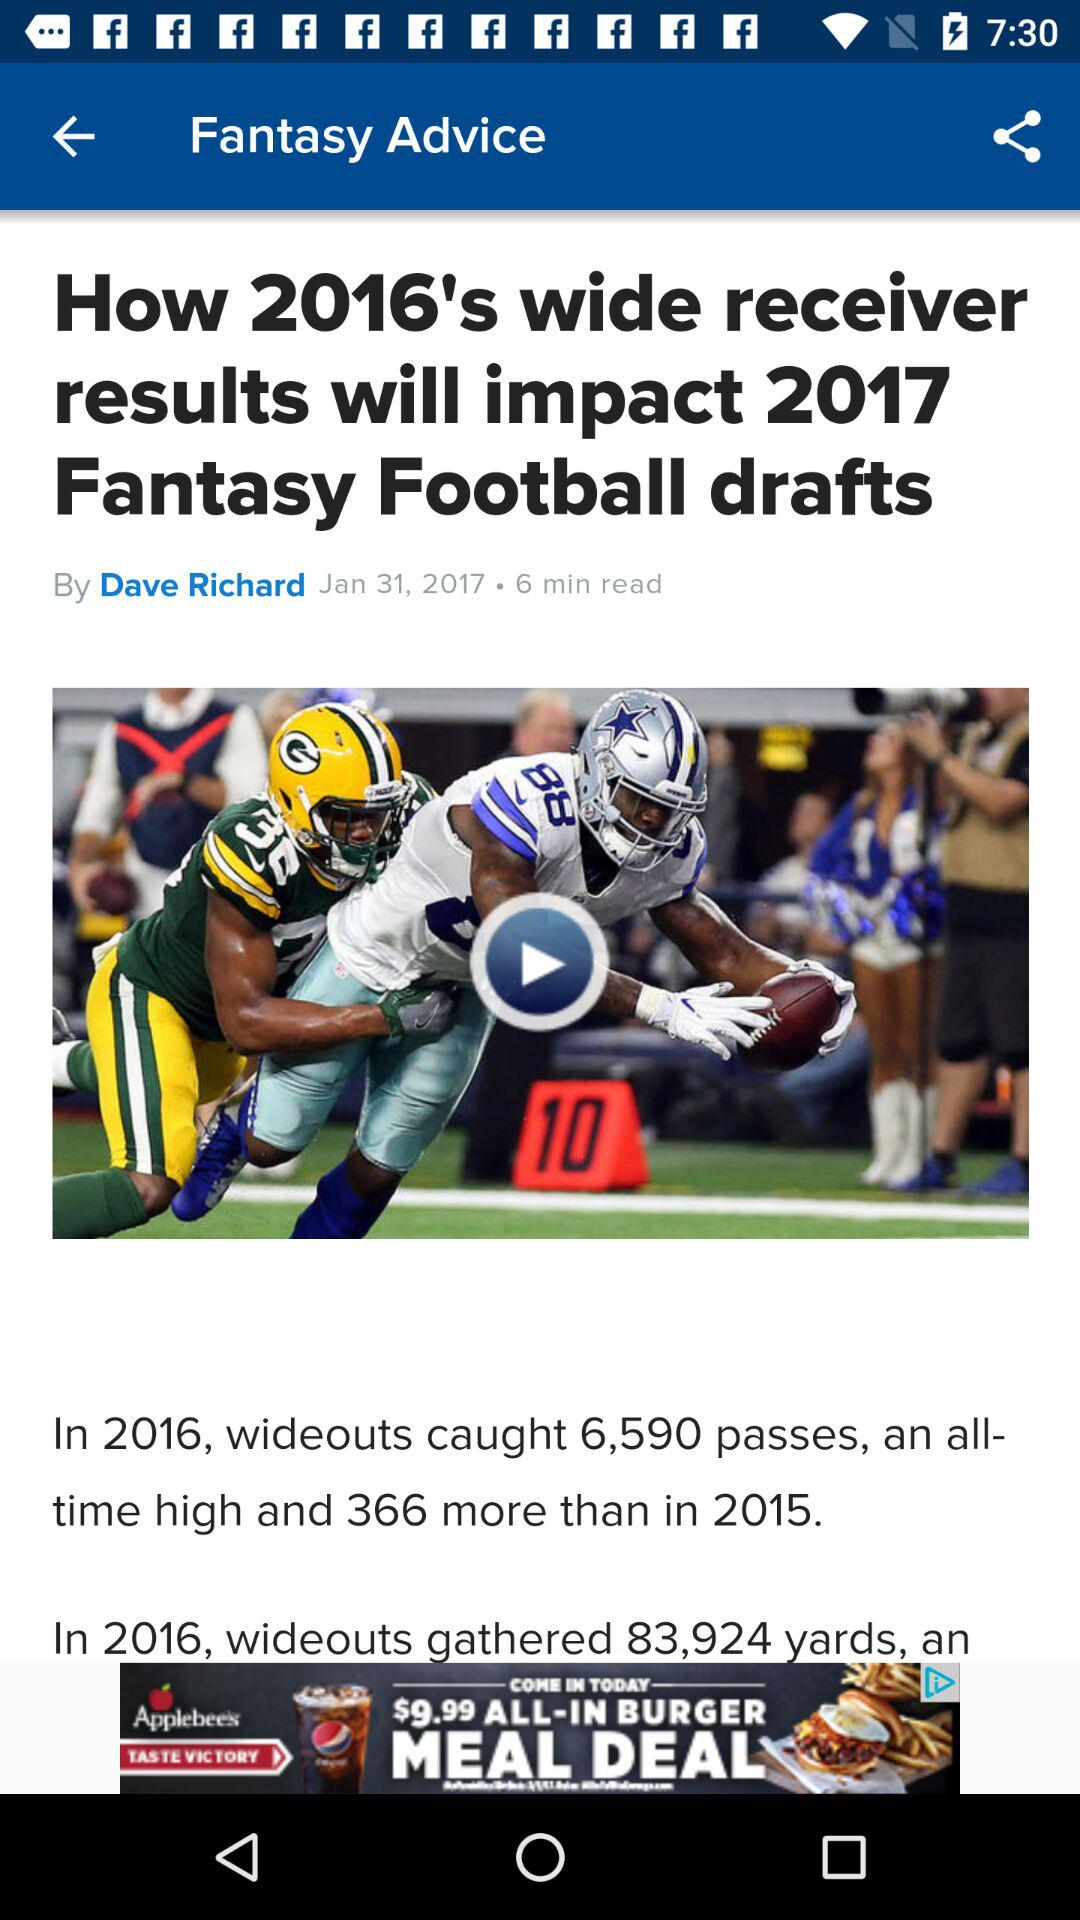Please provide a summary of the article depicted in the image. The image shows an article titled 'How 2016's wide receiver results will impact 2017 Fantasy Football drafts', written by Dave Richard and published on January 31, 2017. The article discusses the statistical performance of wide receivers in the 2016 NFL season and predicts how these results might influence player selection strategies for 2017 fantasy football drafts. 